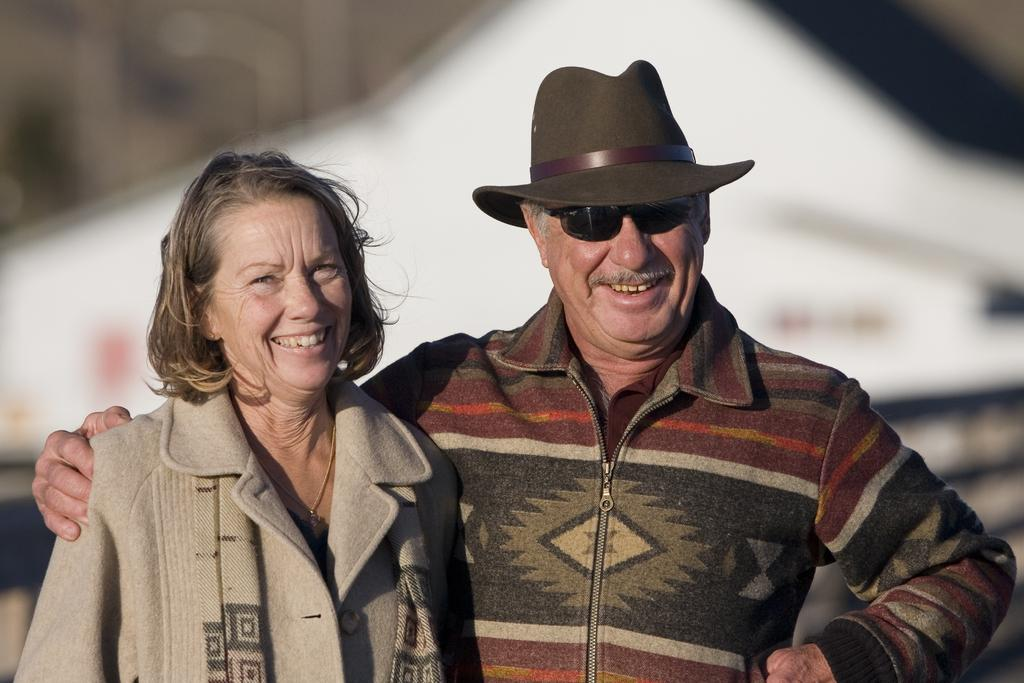Who are the people in the image? There is a man and a woman in the image. Where are the man and woman located in the image? The man and woman are in the center of the image. What color is the shirt worn by the man in the yard? There is no information about a shirt or a yard in the image, as it only mentions a man and a woman in the center. 